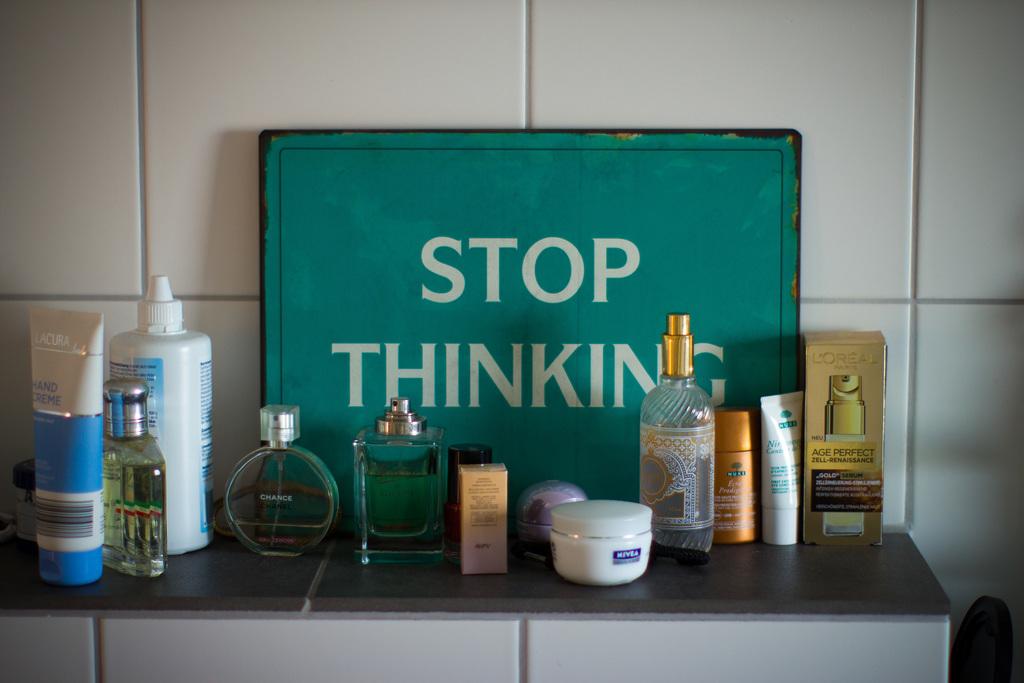Why do i need to stop?
Keep it short and to the point. Thinking. Do you keep thinking?
Offer a terse response. No. 